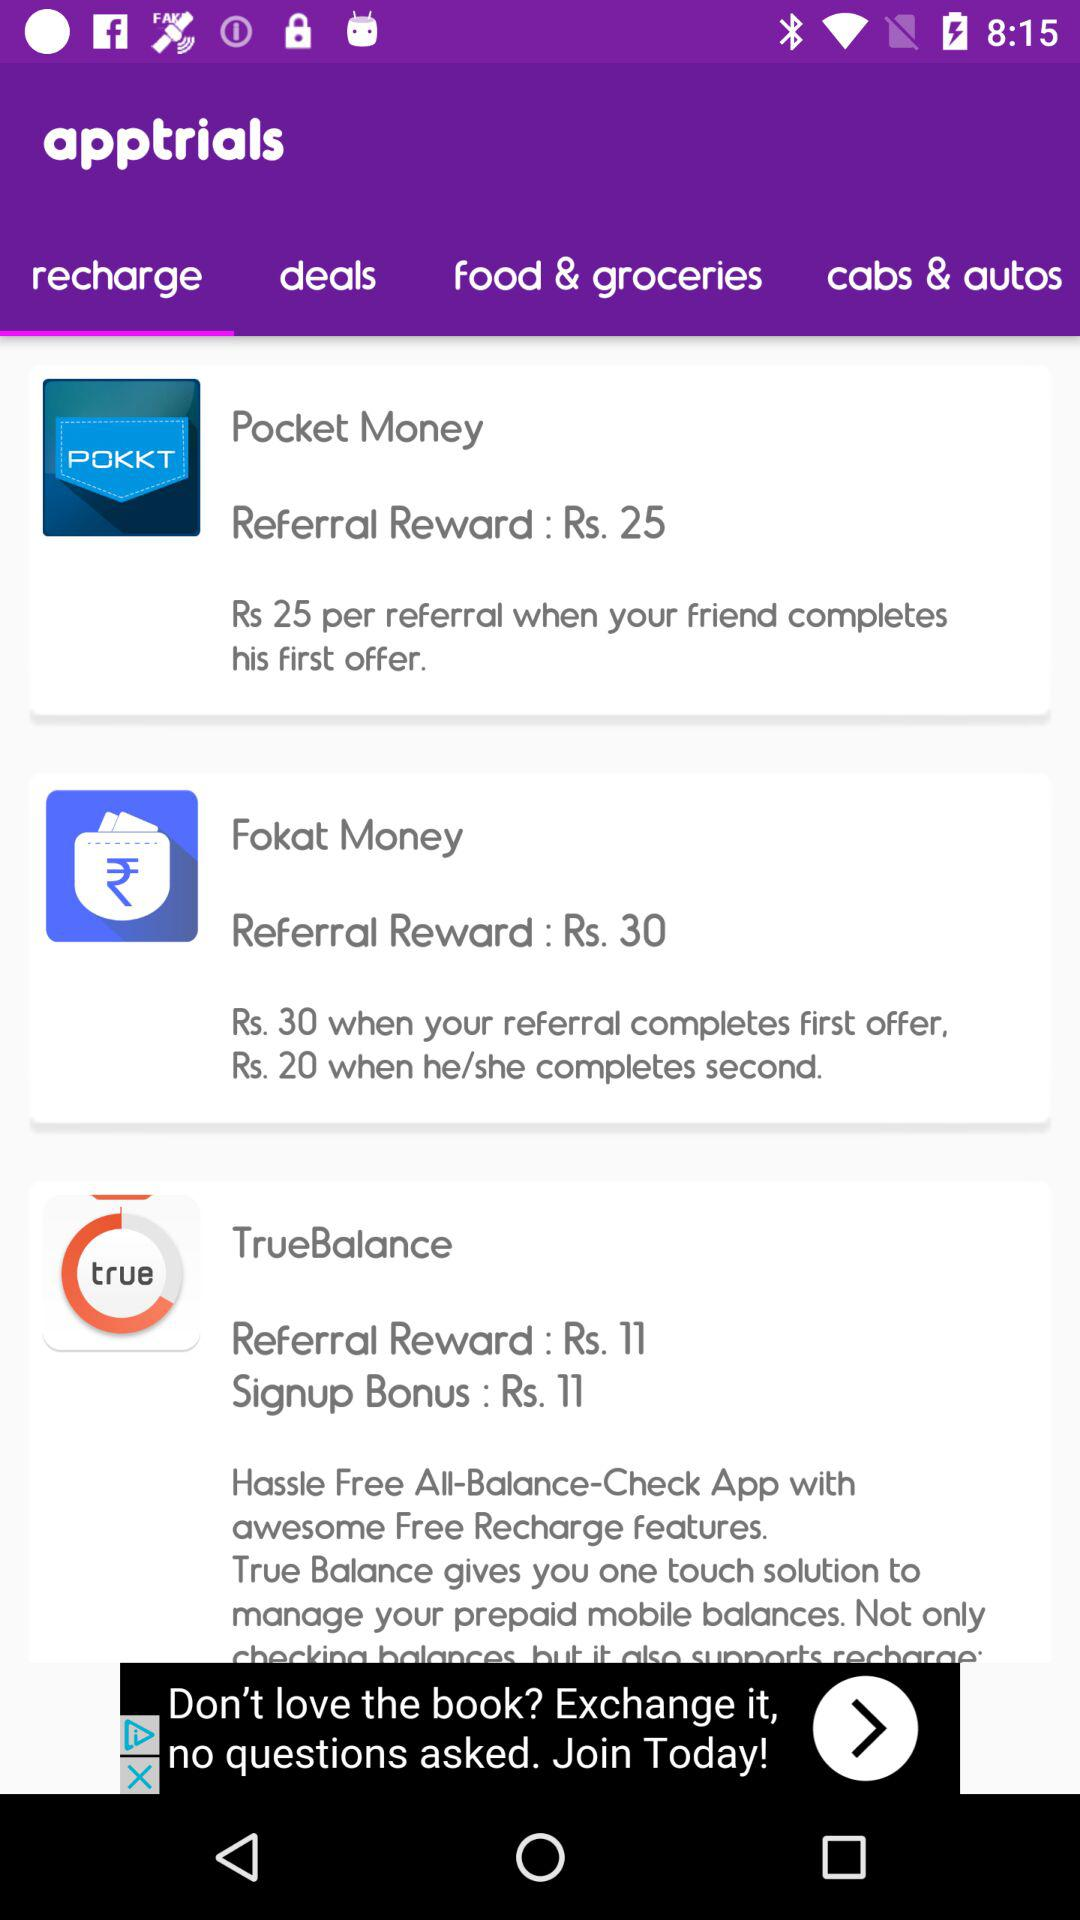How many rupees does TrueBalance give as signup bonus?
Answer the question using a single word or phrase. 11 